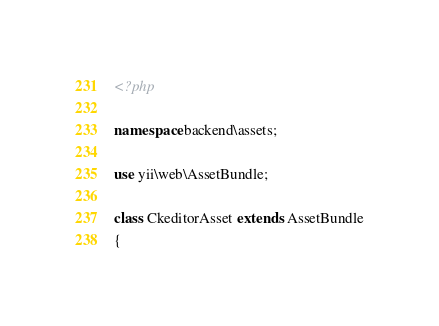Convert code to text. <code><loc_0><loc_0><loc_500><loc_500><_PHP_><?php

namespace backend\assets;

use yii\web\AssetBundle;

class CkeditorAsset extends AssetBundle
{</code> 